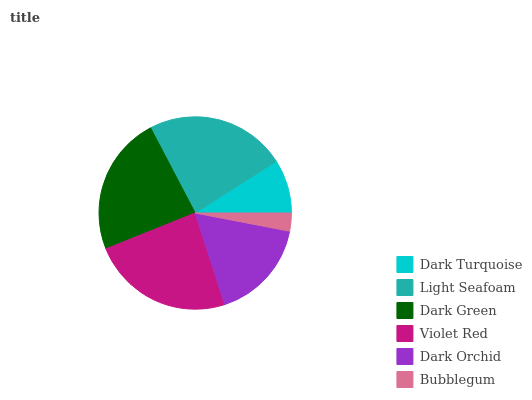Is Bubblegum the minimum?
Answer yes or no. Yes. Is Violet Red the maximum?
Answer yes or no. Yes. Is Light Seafoam the minimum?
Answer yes or no. No. Is Light Seafoam the maximum?
Answer yes or no. No. Is Light Seafoam greater than Dark Turquoise?
Answer yes or no. Yes. Is Dark Turquoise less than Light Seafoam?
Answer yes or no. Yes. Is Dark Turquoise greater than Light Seafoam?
Answer yes or no. No. Is Light Seafoam less than Dark Turquoise?
Answer yes or no. No. Is Dark Green the high median?
Answer yes or no. Yes. Is Dark Orchid the low median?
Answer yes or no. Yes. Is Dark Turquoise the high median?
Answer yes or no. No. Is Violet Red the low median?
Answer yes or no. No. 